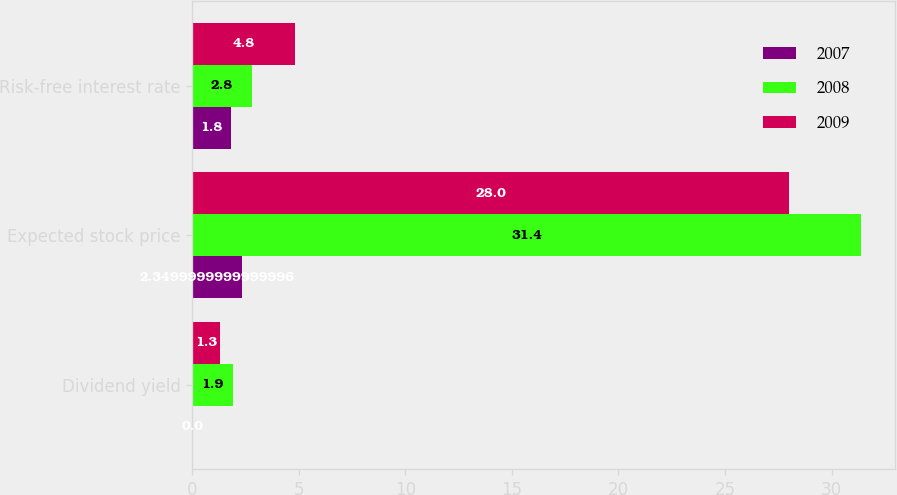Convert chart to OTSL. <chart><loc_0><loc_0><loc_500><loc_500><stacked_bar_chart><ecel><fcel>Dividend yield<fcel>Expected stock price<fcel>Risk-free interest rate<nl><fcel>2007<fcel>0<fcel>2.35<fcel>1.8<nl><fcel>2008<fcel>1.9<fcel>31.4<fcel>2.8<nl><fcel>2009<fcel>1.3<fcel>28<fcel>4.8<nl></chart> 